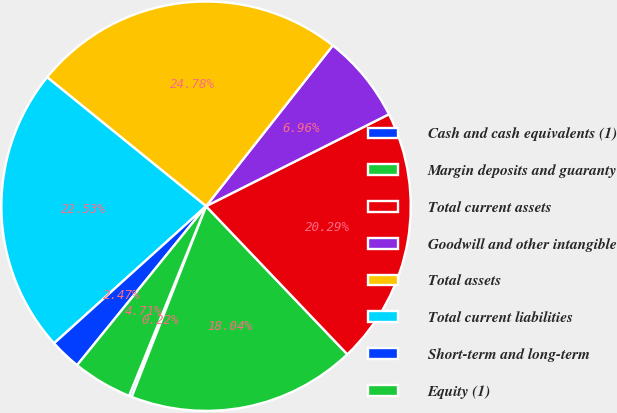Convert chart to OTSL. <chart><loc_0><loc_0><loc_500><loc_500><pie_chart><fcel>Cash and cash equivalents (1)<fcel>Margin deposits and guaranty<fcel>Total current assets<fcel>Goodwill and other intangible<fcel>Total assets<fcel>Total current liabilities<fcel>Short-term and long-term<fcel>Equity (1)<nl><fcel>0.22%<fcel>18.04%<fcel>20.29%<fcel>6.96%<fcel>24.78%<fcel>22.53%<fcel>2.47%<fcel>4.71%<nl></chart> 